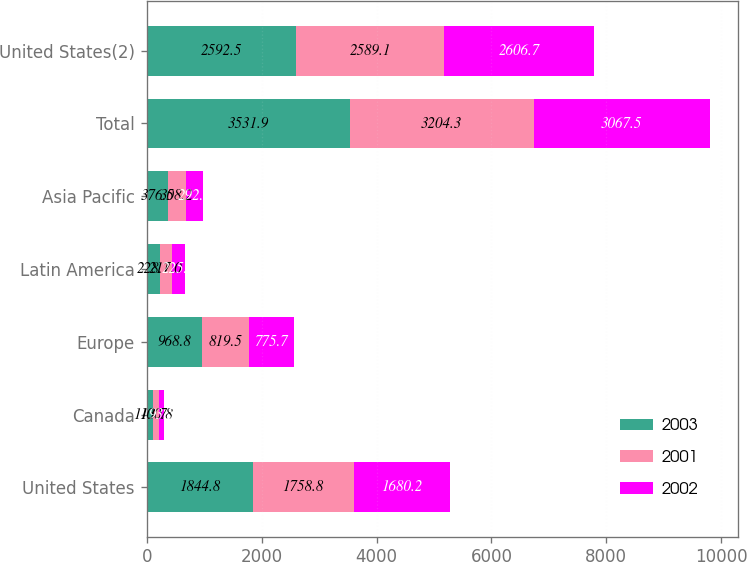<chart> <loc_0><loc_0><loc_500><loc_500><stacked_bar_chart><ecel><fcel>United States<fcel>Canada<fcel>Europe<fcel>Latin America<fcel>Asia Pacific<fcel>Total<fcel>United States(2)<nl><fcel>2003<fcel>1844.8<fcel>113.7<fcel>968.8<fcel>228.1<fcel>376.5<fcel>3531.9<fcel>2592.5<nl><fcel>2001<fcel>1758.8<fcel>100.8<fcel>819.5<fcel>217<fcel>308.2<fcel>3204.3<fcel>2589.1<nl><fcel>2002<fcel>1680.2<fcel>93.5<fcel>775.7<fcel>225.6<fcel>292.5<fcel>3067.5<fcel>2606.7<nl></chart> 